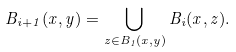<formula> <loc_0><loc_0><loc_500><loc_500>B _ { i + 1 } ( x , y ) = \bigcup _ { z \in B _ { 1 } ( x , y ) } B _ { i } ( x , z ) .</formula> 